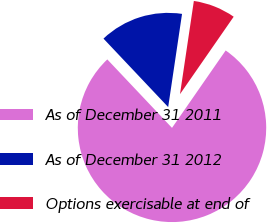Convert chart to OTSL. <chart><loc_0><loc_0><loc_500><loc_500><pie_chart><fcel>As of December 31 2011<fcel>As of December 31 2012<fcel>Options exercisable at end of<nl><fcel>78.3%<fcel>14.4%<fcel>7.3%<nl></chart> 